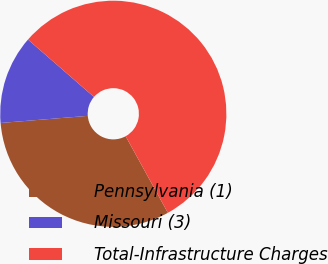<chart> <loc_0><loc_0><loc_500><loc_500><pie_chart><fcel>Pennsylvania (1)<fcel>Missouri (3)<fcel>Total-Infrastructure Charges<nl><fcel>31.72%<fcel>12.69%<fcel>55.59%<nl></chart> 